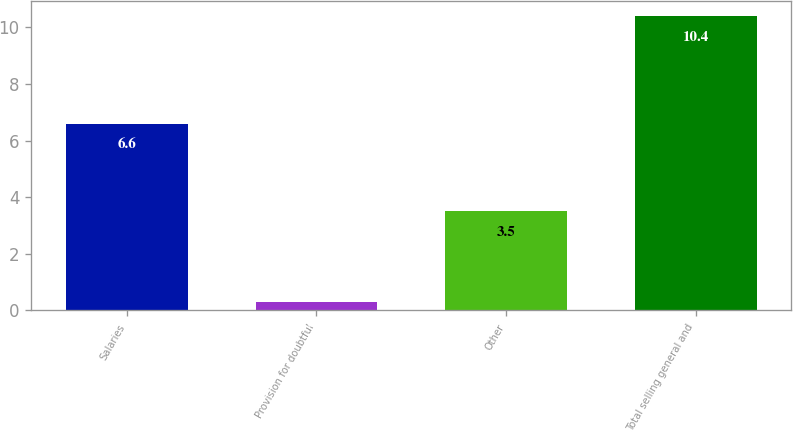Convert chart to OTSL. <chart><loc_0><loc_0><loc_500><loc_500><bar_chart><fcel>Salaries<fcel>Provision for doubtful<fcel>Other<fcel>Total selling general and<nl><fcel>6.6<fcel>0.3<fcel>3.5<fcel>10.4<nl></chart> 